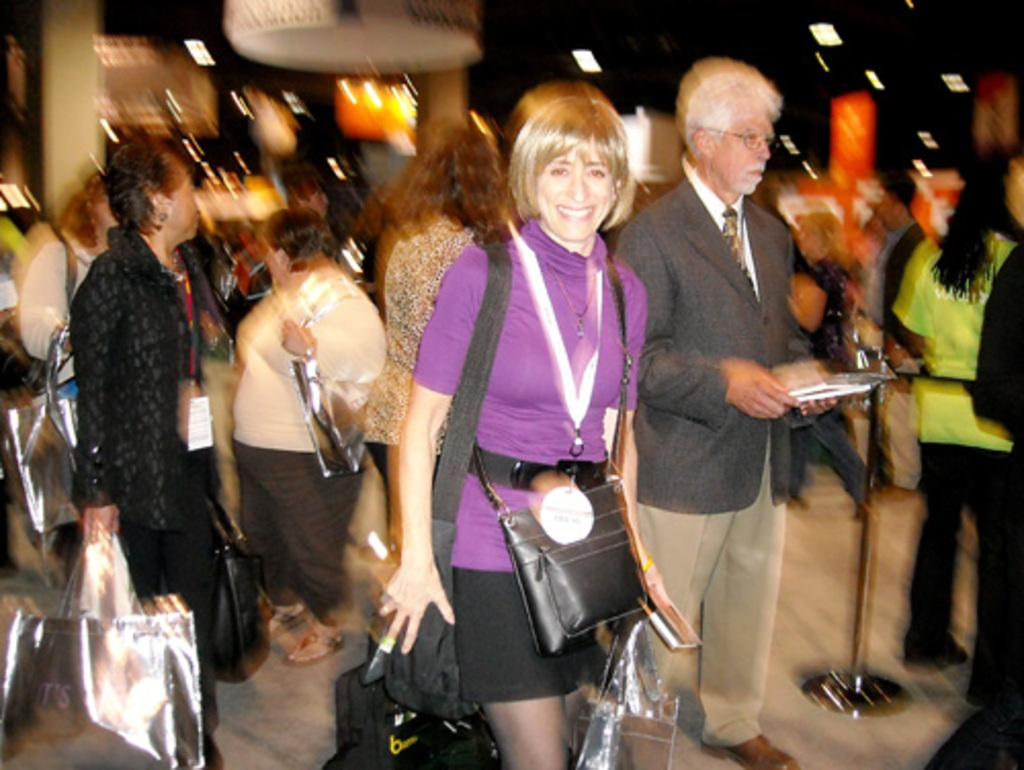Who is the main subject in the image? There is a woman in the image. What is the woman doing in the image? The woman is walking. Can you describe the surrounding environment in the image? There are many persons behind the woman. What type of wool can be seen in the image? There is no wool visible in the image. How many bikes are present in the image? There is no mention of bikes in the image, so it cannot be determined if any are present. 